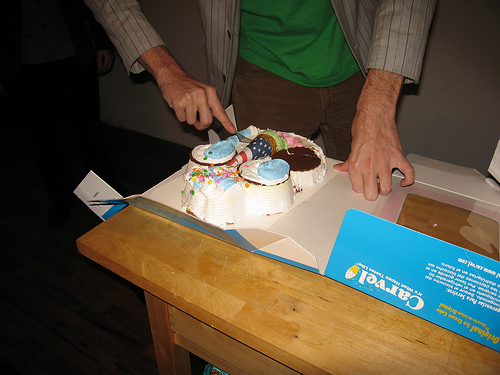What type of event is being depicted in the image? The image seems to depict a casual celebratory event, as suggested by the presence of a cake with candles, which indicates a birthday or similar celebration. 